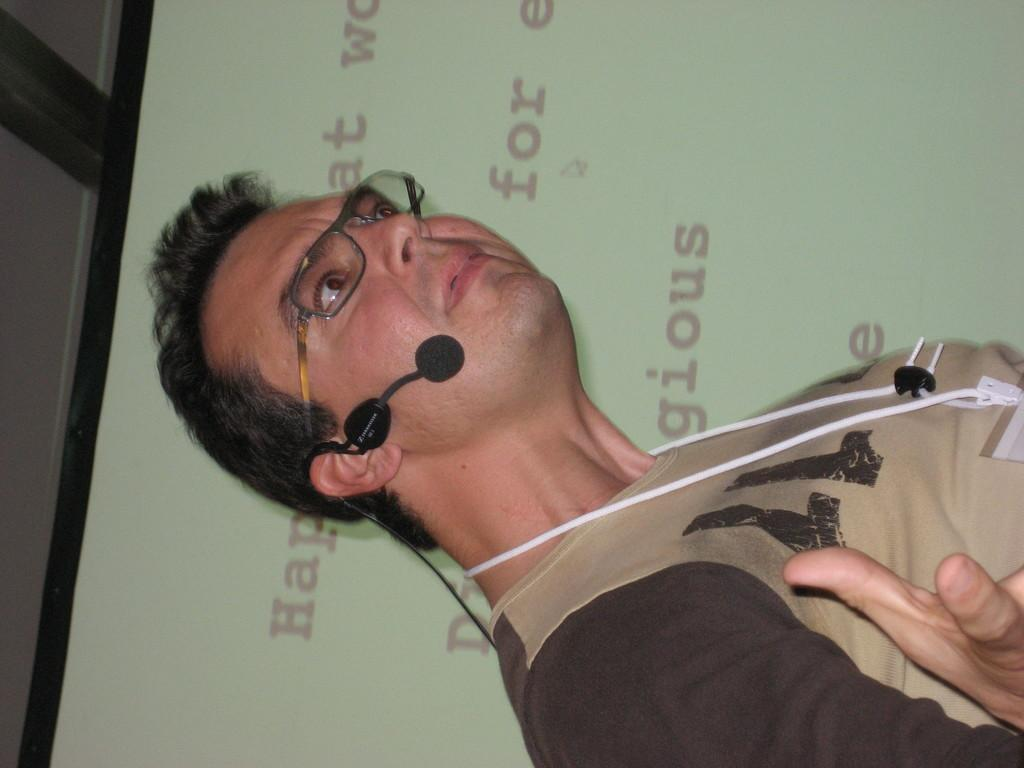Who is the main subject in the image? There is a man in the image. What is the man wearing? The man is wearing a brown t-shirt. Where is the man positioned in the image? The man is standing in the front. What accessory is the man wearing? The man is wearing glasses. What is the man holding in the image? The man is holding a mic. What can be seen on the wall in the image? There is a screen on the wall in the image. How is the image oriented? The image is in a vertical orientation. What type of clouds can be seen in the image? There are no clouds present in the image; it features a man standing in front of a screen on the wall. 